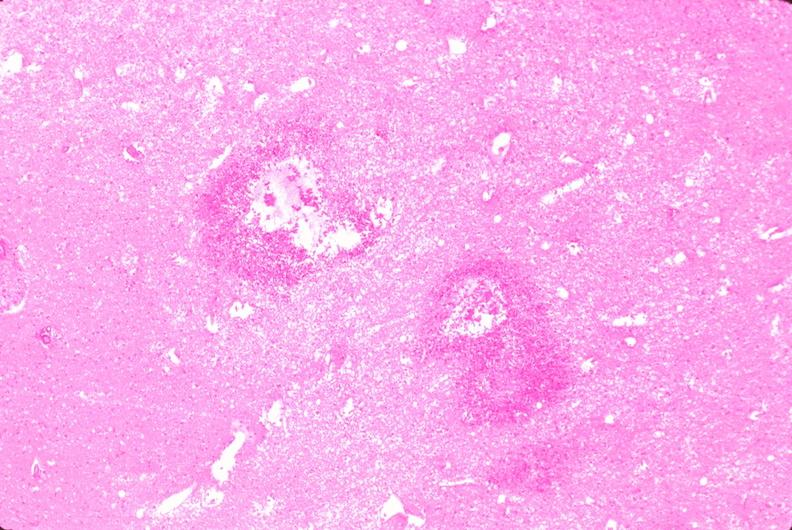s nervous present?
Answer the question using a single word or phrase. Yes 